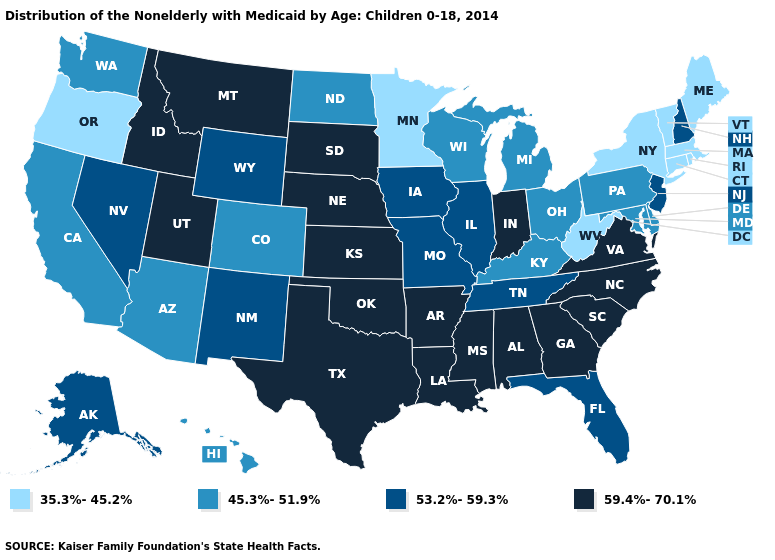What is the value of Maryland?
Short answer required. 45.3%-51.9%. Does Indiana have the highest value in the MidWest?
Write a very short answer. Yes. What is the value of Louisiana?
Be succinct. 59.4%-70.1%. Does Vermont have the highest value in the Northeast?
Answer briefly. No. Which states have the lowest value in the USA?
Quick response, please. Connecticut, Maine, Massachusetts, Minnesota, New York, Oregon, Rhode Island, Vermont, West Virginia. What is the highest value in the USA?
Short answer required. 59.4%-70.1%. Does Pennsylvania have a lower value than North Dakota?
Answer briefly. No. Does the map have missing data?
Answer briefly. No. What is the lowest value in the South?
Give a very brief answer. 35.3%-45.2%. Which states have the lowest value in the USA?
Be succinct. Connecticut, Maine, Massachusetts, Minnesota, New York, Oregon, Rhode Island, Vermont, West Virginia. How many symbols are there in the legend?
Answer briefly. 4. Does New York have the lowest value in the Northeast?
Write a very short answer. Yes. Name the states that have a value in the range 59.4%-70.1%?
Keep it brief. Alabama, Arkansas, Georgia, Idaho, Indiana, Kansas, Louisiana, Mississippi, Montana, Nebraska, North Carolina, Oklahoma, South Carolina, South Dakota, Texas, Utah, Virginia. Name the states that have a value in the range 45.3%-51.9%?
Be succinct. Arizona, California, Colorado, Delaware, Hawaii, Kentucky, Maryland, Michigan, North Dakota, Ohio, Pennsylvania, Washington, Wisconsin. What is the value of Connecticut?
Keep it brief. 35.3%-45.2%. 